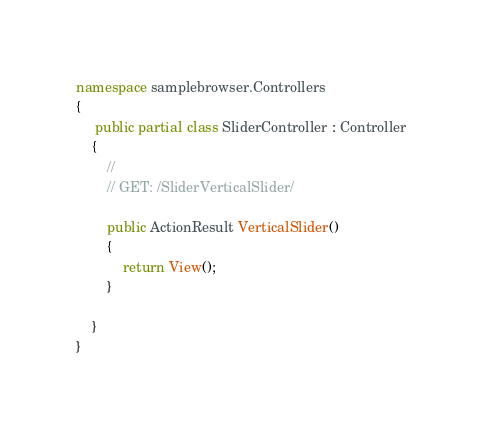<code> <loc_0><loc_0><loc_500><loc_500><_C#_>
namespace samplebrowser.Controllers
{
     public partial class SliderController : Controller
    {
        //
        // GET: /SliderVerticalSlider/

        public ActionResult VerticalSlider()
        {
            return View();
        }

    }
}
</code> 